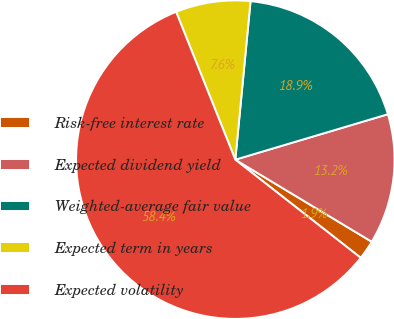<chart> <loc_0><loc_0><loc_500><loc_500><pie_chart><fcel>Risk-free interest rate<fcel>Expected dividend yield<fcel>Weighted-average fair value<fcel>Expected term in years<fcel>Expected volatility<nl><fcel>1.95%<fcel>13.23%<fcel>18.87%<fcel>7.59%<fcel>58.37%<nl></chart> 